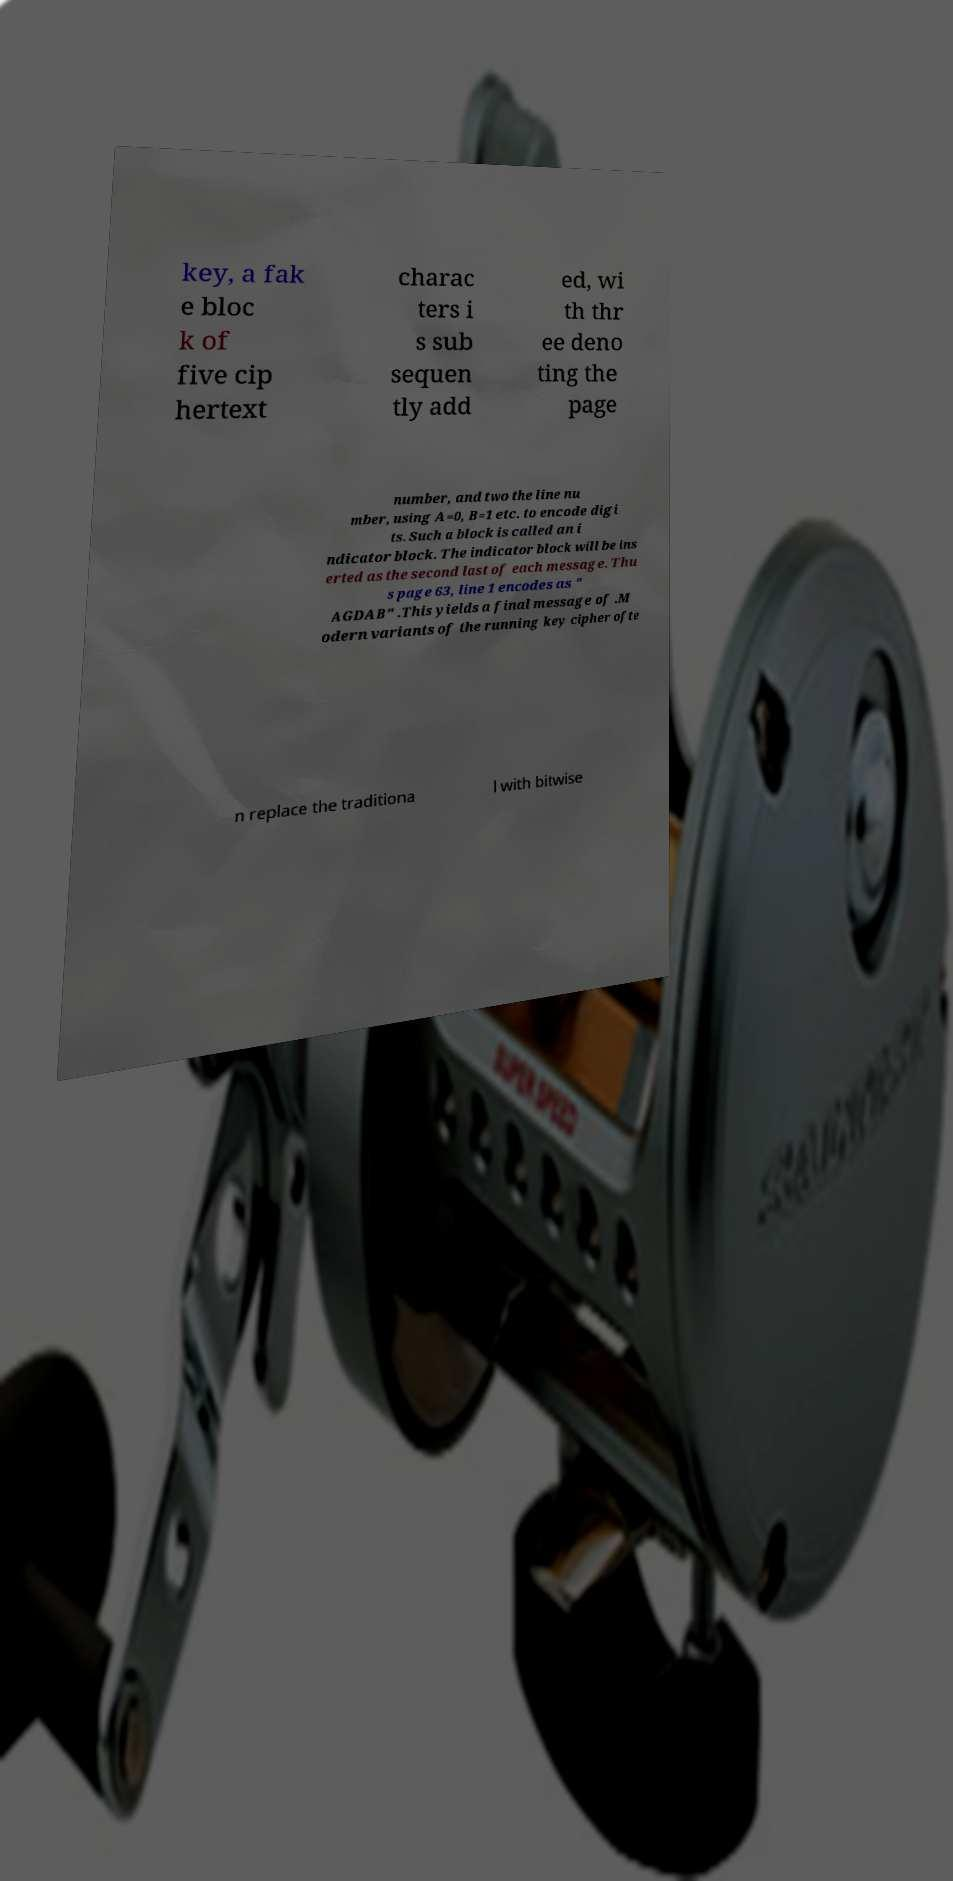Could you assist in decoding the text presented in this image and type it out clearly? key, a fak e bloc k of five cip hertext charac ters i s sub sequen tly add ed, wi th thr ee deno ting the page number, and two the line nu mber, using A=0, B=1 etc. to encode digi ts. Such a block is called an i ndicator block. The indicator block will be ins erted as the second last of each message. Thu s page 63, line 1 encodes as " AGDAB" .This yields a final message of .M odern variants of the running key cipher ofte n replace the traditiona l with bitwise 